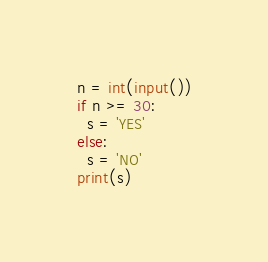<code> <loc_0><loc_0><loc_500><loc_500><_Python_>n = int(input())
if n >= 30:
  s = 'YES'
else:
  s = 'NO'
print(s)</code> 